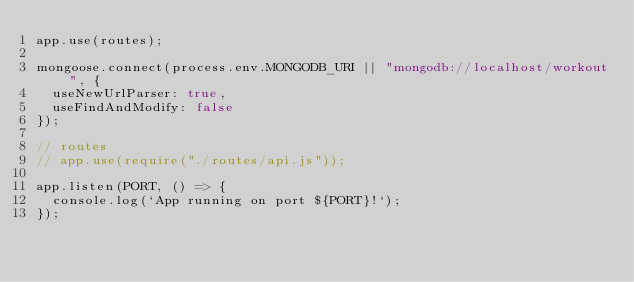<code> <loc_0><loc_0><loc_500><loc_500><_JavaScript_>app.use(routes);

mongoose.connect(process.env.MONGODB_URI || "mongodb://localhost/workout", {
  useNewUrlParser: true,
  useFindAndModify: false
});

// routes
// app.use(require("./routes/api.js"));

app.listen(PORT, () => {
  console.log(`App running on port ${PORT}!`);
});
</code> 